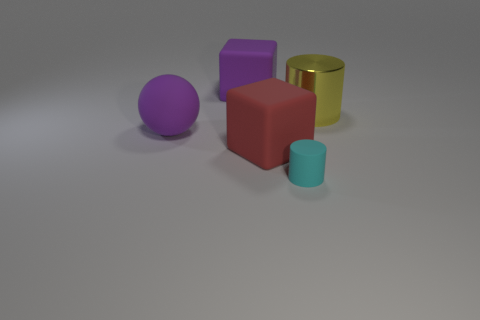Add 2 small cyan metallic cylinders. How many objects exist? 7 Subtract all cyan cylinders. How many cylinders are left? 1 Subtract 2 blocks. How many blocks are left? 0 Subtract all cylinders. How many objects are left? 3 Subtract all gray spheres. Subtract all purple cylinders. How many spheres are left? 1 Subtract all purple metallic things. Subtract all cyan rubber things. How many objects are left? 4 Add 4 blocks. How many blocks are left? 6 Add 2 large purple cylinders. How many large purple cylinders exist? 2 Subtract 0 red cylinders. How many objects are left? 5 